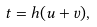Convert formula to latex. <formula><loc_0><loc_0><loc_500><loc_500>t = h ( u + v ) ,</formula> 